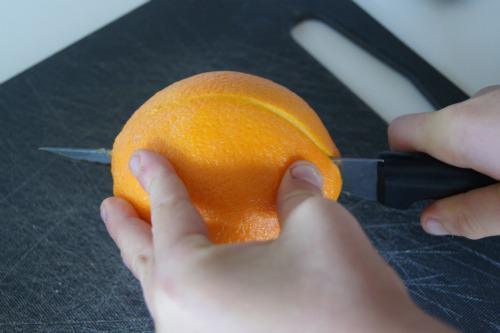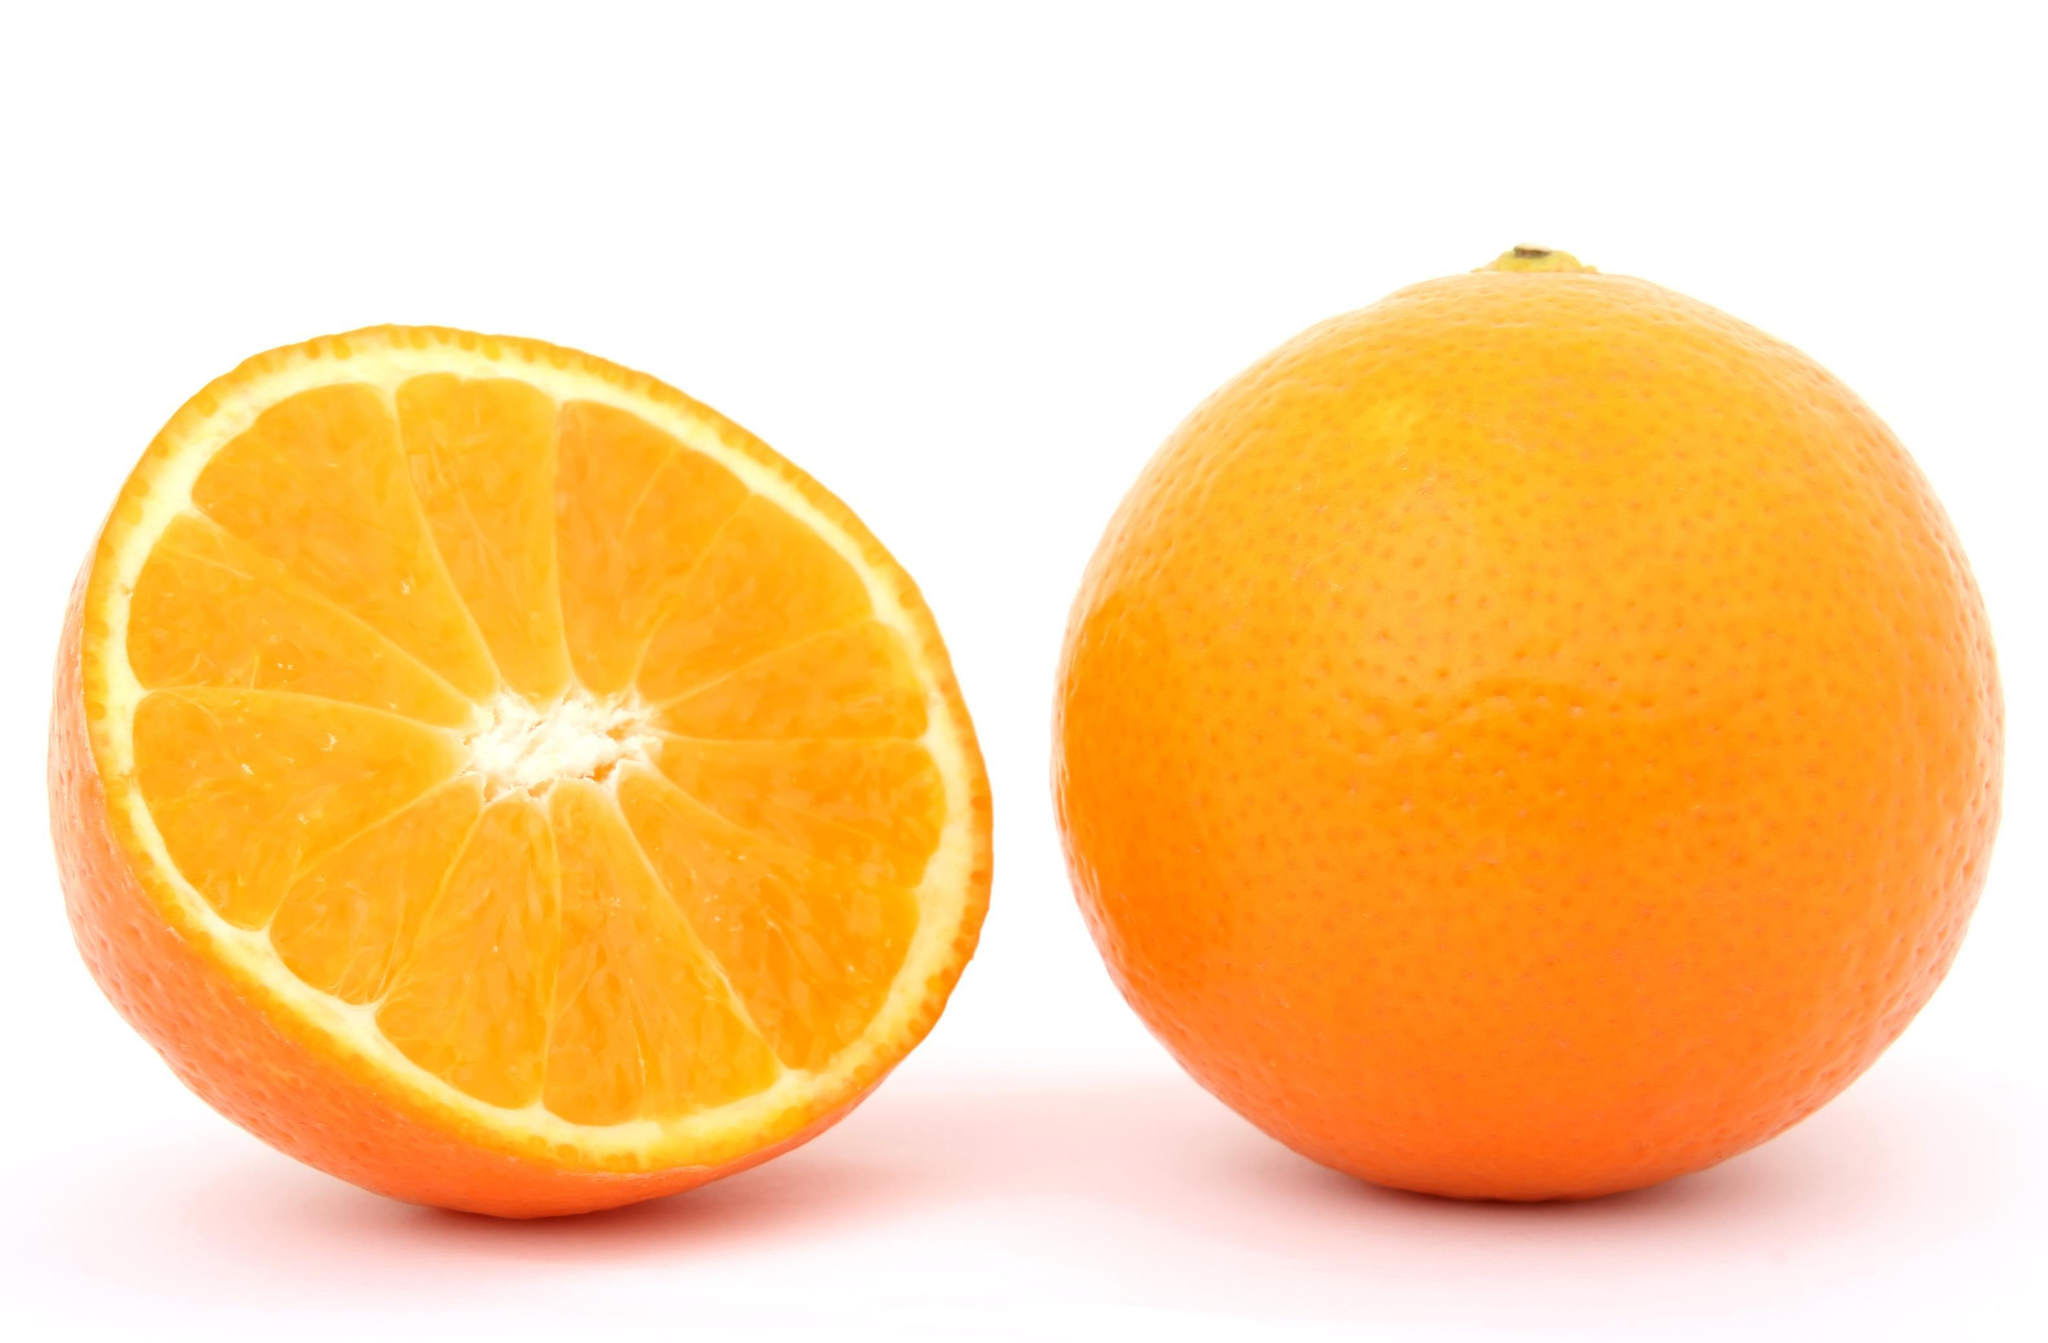The first image is the image on the left, the second image is the image on the right. Evaluate the accuracy of this statement regarding the images: "One image has exactly one and a half oranges.". Is it true? Answer yes or no. Yes. 